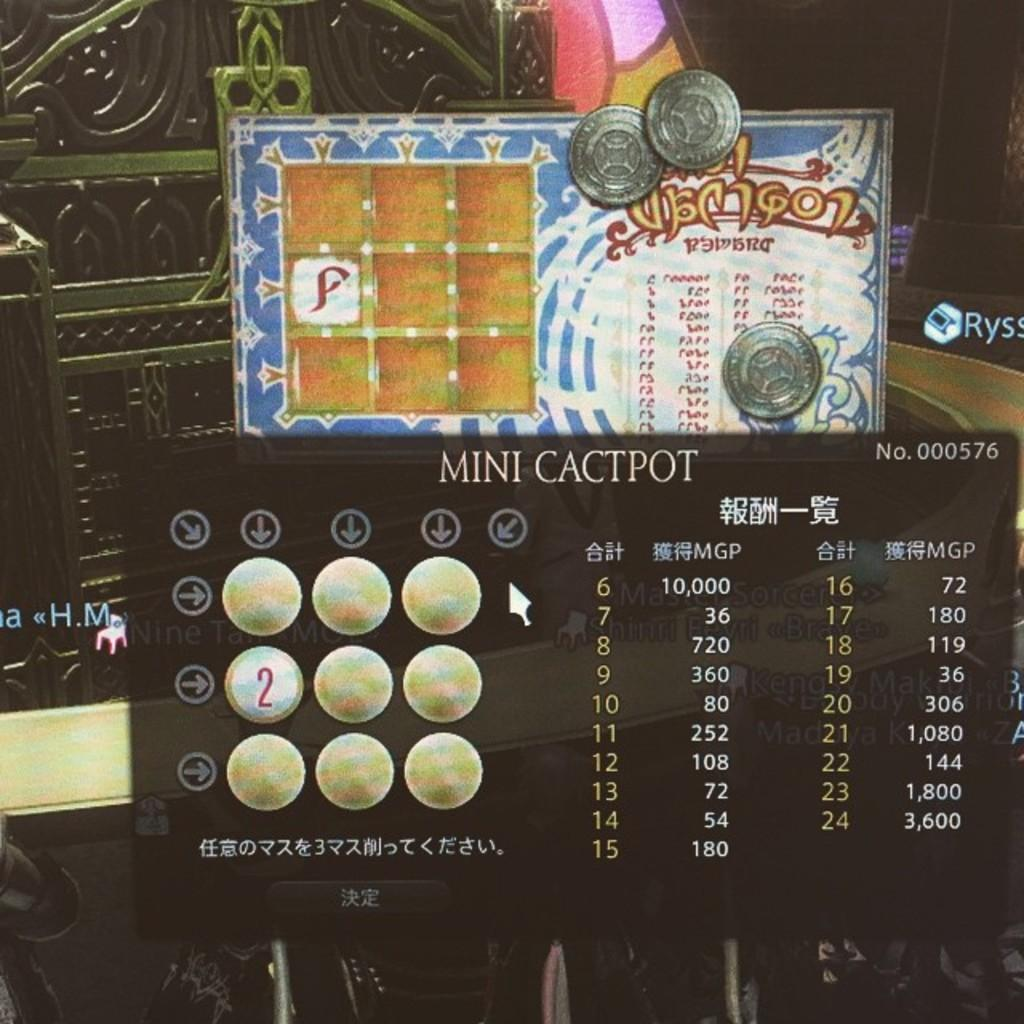<image>
Write a terse but informative summary of the picture. A Mini Cactpot lottery ticket with the number 2 shown on the middle left circle. 